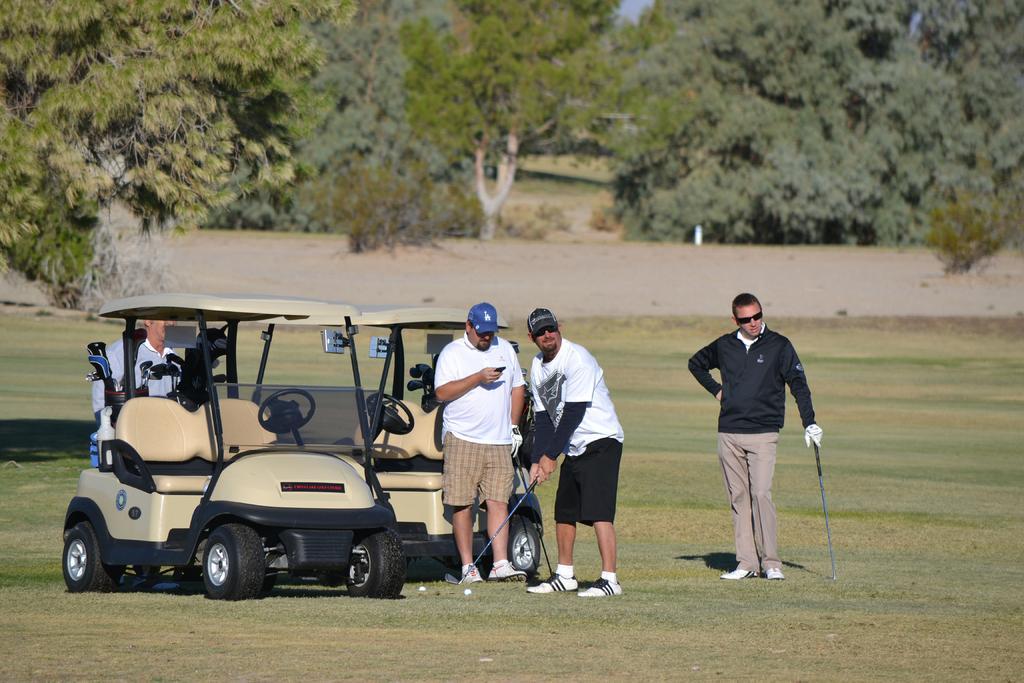In one or two sentences, can you explain what this image depicts? In this image I can see the ground, few persons standing on the ground holding golf sticks in their hands. I can see few vehicles, a person in the vehicle and few trees. In the background I can see the sky. 